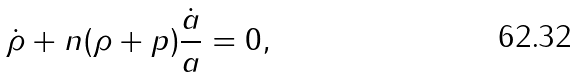<formula> <loc_0><loc_0><loc_500><loc_500>\dot { \rho } + n ( \rho + p ) \frac { \dot { a } } { a } = 0 ,</formula> 